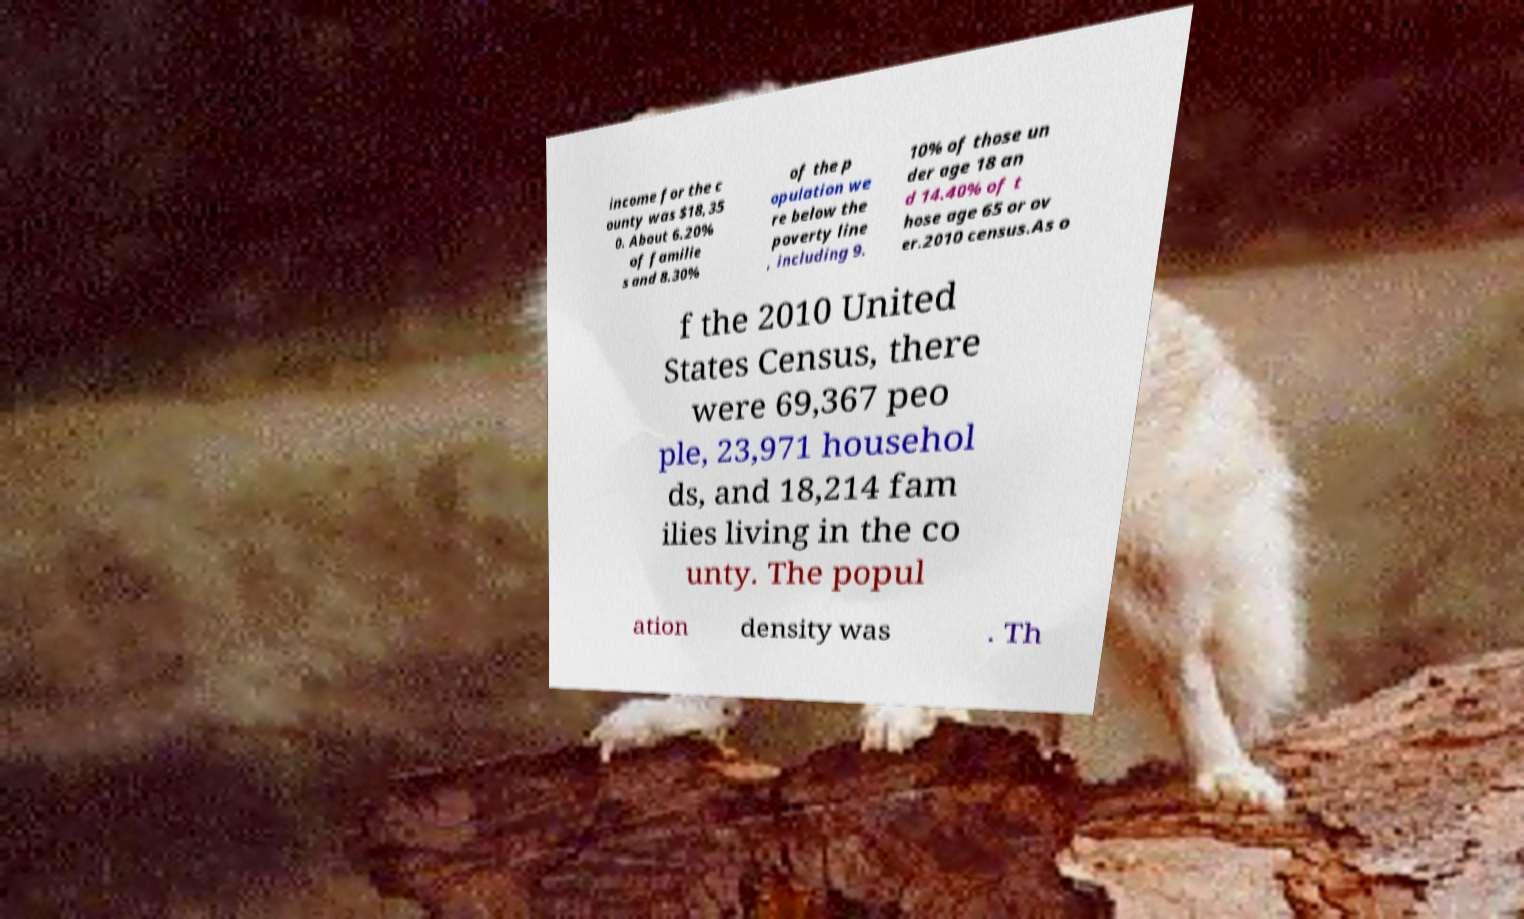Please read and relay the text visible in this image. What does it say? income for the c ounty was $18,35 0. About 6.20% of familie s and 8.30% of the p opulation we re below the poverty line , including 9. 10% of those un der age 18 an d 14.40% of t hose age 65 or ov er.2010 census.As o f the 2010 United States Census, there were 69,367 peo ple, 23,971 househol ds, and 18,214 fam ilies living in the co unty. The popul ation density was . Th 